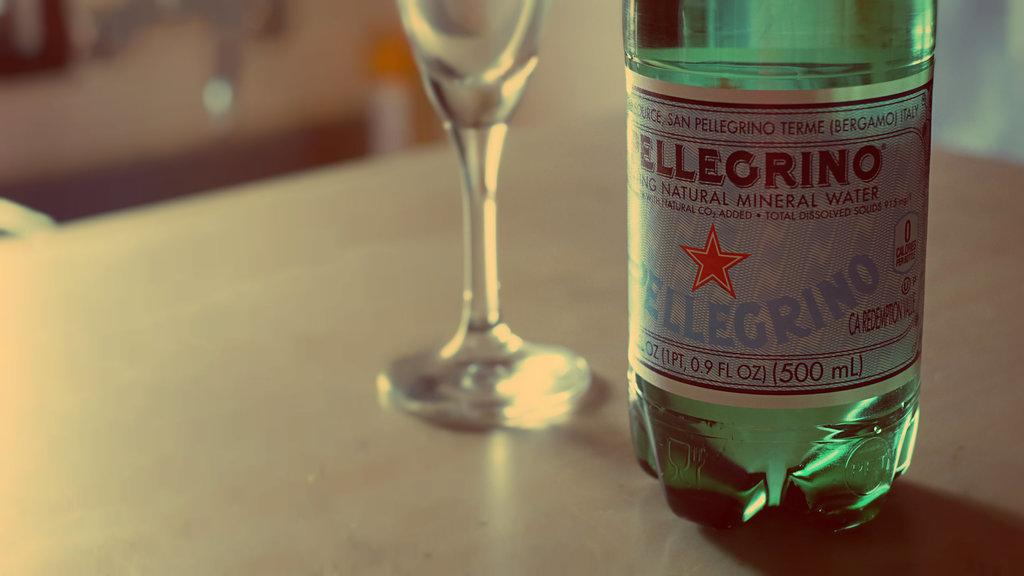What type of container is visible in the image? There is a glass in the image. What other container can be seen in the image? There is a bottle in the image. Where is the bomb located in the image? There is no bomb present in the image. What type of boats can be seen in the image? There are no boats present in the image. 